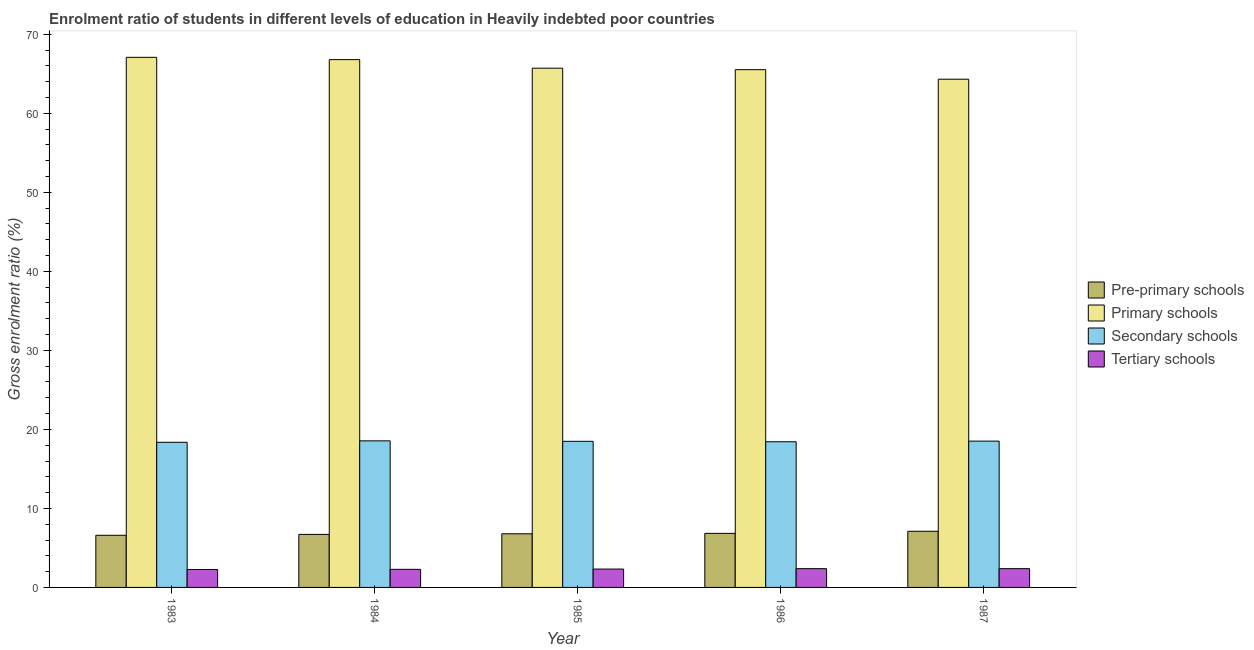How many groups of bars are there?
Your answer should be very brief. 5. Are the number of bars per tick equal to the number of legend labels?
Make the answer very short. Yes. How many bars are there on the 1st tick from the left?
Your response must be concise. 4. In how many cases, is the number of bars for a given year not equal to the number of legend labels?
Offer a terse response. 0. What is the gross enrolment ratio in pre-primary schools in 1984?
Give a very brief answer. 6.71. Across all years, what is the maximum gross enrolment ratio in pre-primary schools?
Your answer should be very brief. 7.11. Across all years, what is the minimum gross enrolment ratio in secondary schools?
Provide a succinct answer. 18.37. What is the total gross enrolment ratio in pre-primary schools in the graph?
Keep it short and to the point. 34.05. What is the difference between the gross enrolment ratio in secondary schools in 1983 and that in 1986?
Your response must be concise. -0.07. What is the difference between the gross enrolment ratio in primary schools in 1985 and the gross enrolment ratio in tertiary schools in 1984?
Your response must be concise. -1.08. What is the average gross enrolment ratio in primary schools per year?
Your response must be concise. 65.89. In the year 1983, what is the difference between the gross enrolment ratio in tertiary schools and gross enrolment ratio in primary schools?
Offer a terse response. 0. In how many years, is the gross enrolment ratio in pre-primary schools greater than 18 %?
Keep it short and to the point. 0. What is the ratio of the gross enrolment ratio in primary schools in 1983 to that in 1984?
Give a very brief answer. 1. Is the gross enrolment ratio in primary schools in 1984 less than that in 1986?
Make the answer very short. No. What is the difference between the highest and the second highest gross enrolment ratio in primary schools?
Keep it short and to the point. 0.29. What is the difference between the highest and the lowest gross enrolment ratio in pre-primary schools?
Keep it short and to the point. 0.51. Is the sum of the gross enrolment ratio in tertiary schools in 1985 and 1987 greater than the maximum gross enrolment ratio in primary schools across all years?
Your answer should be very brief. Yes. Is it the case that in every year, the sum of the gross enrolment ratio in tertiary schools and gross enrolment ratio in secondary schools is greater than the sum of gross enrolment ratio in primary schools and gross enrolment ratio in pre-primary schools?
Ensure brevity in your answer.  No. What does the 3rd bar from the left in 1984 represents?
Make the answer very short. Secondary schools. What does the 2nd bar from the right in 1987 represents?
Provide a short and direct response. Secondary schools. Is it the case that in every year, the sum of the gross enrolment ratio in pre-primary schools and gross enrolment ratio in primary schools is greater than the gross enrolment ratio in secondary schools?
Offer a very short reply. Yes. Are all the bars in the graph horizontal?
Offer a terse response. No. What is the difference between two consecutive major ticks on the Y-axis?
Make the answer very short. 10. Are the values on the major ticks of Y-axis written in scientific E-notation?
Your answer should be very brief. No. Does the graph contain any zero values?
Your answer should be compact. No. Where does the legend appear in the graph?
Your response must be concise. Center right. How many legend labels are there?
Ensure brevity in your answer.  4. How are the legend labels stacked?
Give a very brief answer. Vertical. What is the title of the graph?
Make the answer very short. Enrolment ratio of students in different levels of education in Heavily indebted poor countries. What is the label or title of the Y-axis?
Your response must be concise. Gross enrolment ratio (%). What is the Gross enrolment ratio (%) of Pre-primary schools in 1983?
Provide a short and direct response. 6.6. What is the Gross enrolment ratio (%) of Primary schools in 1983?
Offer a terse response. 67.09. What is the Gross enrolment ratio (%) of Secondary schools in 1983?
Provide a succinct answer. 18.37. What is the Gross enrolment ratio (%) in Tertiary schools in 1983?
Your response must be concise. 2.27. What is the Gross enrolment ratio (%) in Pre-primary schools in 1984?
Provide a short and direct response. 6.71. What is the Gross enrolment ratio (%) in Primary schools in 1984?
Offer a very short reply. 66.8. What is the Gross enrolment ratio (%) in Secondary schools in 1984?
Your response must be concise. 18.55. What is the Gross enrolment ratio (%) of Tertiary schools in 1984?
Your answer should be compact. 2.29. What is the Gross enrolment ratio (%) in Pre-primary schools in 1985?
Offer a very short reply. 6.79. What is the Gross enrolment ratio (%) of Primary schools in 1985?
Ensure brevity in your answer.  65.72. What is the Gross enrolment ratio (%) in Secondary schools in 1985?
Offer a very short reply. 18.49. What is the Gross enrolment ratio (%) of Tertiary schools in 1985?
Give a very brief answer. 2.33. What is the Gross enrolment ratio (%) of Pre-primary schools in 1986?
Keep it short and to the point. 6.84. What is the Gross enrolment ratio (%) in Primary schools in 1986?
Give a very brief answer. 65.53. What is the Gross enrolment ratio (%) of Secondary schools in 1986?
Ensure brevity in your answer.  18.44. What is the Gross enrolment ratio (%) in Tertiary schools in 1986?
Give a very brief answer. 2.38. What is the Gross enrolment ratio (%) in Pre-primary schools in 1987?
Offer a terse response. 7.11. What is the Gross enrolment ratio (%) of Primary schools in 1987?
Your answer should be compact. 64.32. What is the Gross enrolment ratio (%) of Secondary schools in 1987?
Make the answer very short. 18.52. What is the Gross enrolment ratio (%) in Tertiary schools in 1987?
Make the answer very short. 2.38. Across all years, what is the maximum Gross enrolment ratio (%) in Pre-primary schools?
Give a very brief answer. 7.11. Across all years, what is the maximum Gross enrolment ratio (%) in Primary schools?
Make the answer very short. 67.09. Across all years, what is the maximum Gross enrolment ratio (%) in Secondary schools?
Give a very brief answer. 18.55. Across all years, what is the maximum Gross enrolment ratio (%) in Tertiary schools?
Keep it short and to the point. 2.38. Across all years, what is the minimum Gross enrolment ratio (%) of Pre-primary schools?
Give a very brief answer. 6.6. Across all years, what is the minimum Gross enrolment ratio (%) in Primary schools?
Provide a succinct answer. 64.32. Across all years, what is the minimum Gross enrolment ratio (%) of Secondary schools?
Your answer should be very brief. 18.37. Across all years, what is the minimum Gross enrolment ratio (%) in Tertiary schools?
Provide a succinct answer. 2.27. What is the total Gross enrolment ratio (%) in Pre-primary schools in the graph?
Your answer should be compact. 34.05. What is the total Gross enrolment ratio (%) of Primary schools in the graph?
Your answer should be compact. 329.47. What is the total Gross enrolment ratio (%) in Secondary schools in the graph?
Ensure brevity in your answer.  92.37. What is the total Gross enrolment ratio (%) of Tertiary schools in the graph?
Make the answer very short. 11.64. What is the difference between the Gross enrolment ratio (%) of Pre-primary schools in 1983 and that in 1984?
Provide a short and direct response. -0.11. What is the difference between the Gross enrolment ratio (%) of Primary schools in 1983 and that in 1984?
Keep it short and to the point. 0.29. What is the difference between the Gross enrolment ratio (%) in Secondary schools in 1983 and that in 1984?
Your answer should be very brief. -0.18. What is the difference between the Gross enrolment ratio (%) of Tertiary schools in 1983 and that in 1984?
Provide a succinct answer. -0.02. What is the difference between the Gross enrolment ratio (%) of Pre-primary schools in 1983 and that in 1985?
Offer a very short reply. -0.19. What is the difference between the Gross enrolment ratio (%) in Primary schools in 1983 and that in 1985?
Your answer should be very brief. 1.37. What is the difference between the Gross enrolment ratio (%) of Secondary schools in 1983 and that in 1985?
Ensure brevity in your answer.  -0.12. What is the difference between the Gross enrolment ratio (%) in Tertiary schools in 1983 and that in 1985?
Provide a succinct answer. -0.06. What is the difference between the Gross enrolment ratio (%) in Pre-primary schools in 1983 and that in 1986?
Keep it short and to the point. -0.24. What is the difference between the Gross enrolment ratio (%) of Primary schools in 1983 and that in 1986?
Provide a short and direct response. 1.56. What is the difference between the Gross enrolment ratio (%) of Secondary schools in 1983 and that in 1986?
Offer a terse response. -0.07. What is the difference between the Gross enrolment ratio (%) in Tertiary schools in 1983 and that in 1986?
Keep it short and to the point. -0.11. What is the difference between the Gross enrolment ratio (%) of Pre-primary schools in 1983 and that in 1987?
Provide a succinct answer. -0.51. What is the difference between the Gross enrolment ratio (%) in Primary schools in 1983 and that in 1987?
Offer a terse response. 2.77. What is the difference between the Gross enrolment ratio (%) of Secondary schools in 1983 and that in 1987?
Make the answer very short. -0.15. What is the difference between the Gross enrolment ratio (%) in Tertiary schools in 1983 and that in 1987?
Your answer should be compact. -0.11. What is the difference between the Gross enrolment ratio (%) of Pre-primary schools in 1984 and that in 1985?
Your answer should be very brief. -0.08. What is the difference between the Gross enrolment ratio (%) of Primary schools in 1984 and that in 1985?
Provide a succinct answer. 1.08. What is the difference between the Gross enrolment ratio (%) of Secondary schools in 1984 and that in 1985?
Give a very brief answer. 0.06. What is the difference between the Gross enrolment ratio (%) in Tertiary schools in 1984 and that in 1985?
Your answer should be very brief. -0.04. What is the difference between the Gross enrolment ratio (%) of Pre-primary schools in 1984 and that in 1986?
Provide a succinct answer. -0.13. What is the difference between the Gross enrolment ratio (%) of Primary schools in 1984 and that in 1986?
Ensure brevity in your answer.  1.27. What is the difference between the Gross enrolment ratio (%) in Secondary schools in 1984 and that in 1986?
Ensure brevity in your answer.  0.12. What is the difference between the Gross enrolment ratio (%) of Tertiary schools in 1984 and that in 1986?
Ensure brevity in your answer.  -0.09. What is the difference between the Gross enrolment ratio (%) of Pre-primary schools in 1984 and that in 1987?
Ensure brevity in your answer.  -0.39. What is the difference between the Gross enrolment ratio (%) of Primary schools in 1984 and that in 1987?
Your answer should be very brief. 2.48. What is the difference between the Gross enrolment ratio (%) in Secondary schools in 1984 and that in 1987?
Your answer should be very brief. 0.03. What is the difference between the Gross enrolment ratio (%) in Tertiary schools in 1984 and that in 1987?
Offer a terse response. -0.09. What is the difference between the Gross enrolment ratio (%) in Pre-primary schools in 1985 and that in 1986?
Ensure brevity in your answer.  -0.05. What is the difference between the Gross enrolment ratio (%) of Primary schools in 1985 and that in 1986?
Keep it short and to the point. 0.19. What is the difference between the Gross enrolment ratio (%) of Secondary schools in 1985 and that in 1986?
Ensure brevity in your answer.  0.06. What is the difference between the Gross enrolment ratio (%) of Tertiary schools in 1985 and that in 1986?
Your answer should be very brief. -0.05. What is the difference between the Gross enrolment ratio (%) of Pre-primary schools in 1985 and that in 1987?
Offer a very short reply. -0.32. What is the difference between the Gross enrolment ratio (%) of Primary schools in 1985 and that in 1987?
Provide a succinct answer. 1.4. What is the difference between the Gross enrolment ratio (%) in Secondary schools in 1985 and that in 1987?
Keep it short and to the point. -0.02. What is the difference between the Gross enrolment ratio (%) of Tertiary schools in 1985 and that in 1987?
Make the answer very short. -0.05. What is the difference between the Gross enrolment ratio (%) in Pre-primary schools in 1986 and that in 1987?
Your answer should be very brief. -0.26. What is the difference between the Gross enrolment ratio (%) of Primary schools in 1986 and that in 1987?
Make the answer very short. 1.21. What is the difference between the Gross enrolment ratio (%) in Secondary schools in 1986 and that in 1987?
Your answer should be very brief. -0.08. What is the difference between the Gross enrolment ratio (%) in Tertiary schools in 1986 and that in 1987?
Your answer should be compact. -0. What is the difference between the Gross enrolment ratio (%) of Pre-primary schools in 1983 and the Gross enrolment ratio (%) of Primary schools in 1984?
Offer a very short reply. -60.2. What is the difference between the Gross enrolment ratio (%) of Pre-primary schools in 1983 and the Gross enrolment ratio (%) of Secondary schools in 1984?
Your response must be concise. -11.95. What is the difference between the Gross enrolment ratio (%) in Pre-primary schools in 1983 and the Gross enrolment ratio (%) in Tertiary schools in 1984?
Provide a succinct answer. 4.31. What is the difference between the Gross enrolment ratio (%) of Primary schools in 1983 and the Gross enrolment ratio (%) of Secondary schools in 1984?
Your response must be concise. 48.54. What is the difference between the Gross enrolment ratio (%) in Primary schools in 1983 and the Gross enrolment ratio (%) in Tertiary schools in 1984?
Offer a terse response. 64.8. What is the difference between the Gross enrolment ratio (%) of Secondary schools in 1983 and the Gross enrolment ratio (%) of Tertiary schools in 1984?
Provide a succinct answer. 16.08. What is the difference between the Gross enrolment ratio (%) of Pre-primary schools in 1983 and the Gross enrolment ratio (%) of Primary schools in 1985?
Make the answer very short. -59.12. What is the difference between the Gross enrolment ratio (%) of Pre-primary schools in 1983 and the Gross enrolment ratio (%) of Secondary schools in 1985?
Provide a short and direct response. -11.89. What is the difference between the Gross enrolment ratio (%) of Pre-primary schools in 1983 and the Gross enrolment ratio (%) of Tertiary schools in 1985?
Provide a short and direct response. 4.27. What is the difference between the Gross enrolment ratio (%) in Primary schools in 1983 and the Gross enrolment ratio (%) in Secondary schools in 1985?
Offer a very short reply. 48.6. What is the difference between the Gross enrolment ratio (%) in Primary schools in 1983 and the Gross enrolment ratio (%) in Tertiary schools in 1985?
Provide a short and direct response. 64.77. What is the difference between the Gross enrolment ratio (%) in Secondary schools in 1983 and the Gross enrolment ratio (%) in Tertiary schools in 1985?
Make the answer very short. 16.04. What is the difference between the Gross enrolment ratio (%) of Pre-primary schools in 1983 and the Gross enrolment ratio (%) of Primary schools in 1986?
Give a very brief answer. -58.93. What is the difference between the Gross enrolment ratio (%) of Pre-primary schools in 1983 and the Gross enrolment ratio (%) of Secondary schools in 1986?
Keep it short and to the point. -11.84. What is the difference between the Gross enrolment ratio (%) in Pre-primary schools in 1983 and the Gross enrolment ratio (%) in Tertiary schools in 1986?
Ensure brevity in your answer.  4.22. What is the difference between the Gross enrolment ratio (%) of Primary schools in 1983 and the Gross enrolment ratio (%) of Secondary schools in 1986?
Make the answer very short. 48.66. What is the difference between the Gross enrolment ratio (%) of Primary schools in 1983 and the Gross enrolment ratio (%) of Tertiary schools in 1986?
Offer a very short reply. 64.72. What is the difference between the Gross enrolment ratio (%) in Secondary schools in 1983 and the Gross enrolment ratio (%) in Tertiary schools in 1986?
Your response must be concise. 15.99. What is the difference between the Gross enrolment ratio (%) in Pre-primary schools in 1983 and the Gross enrolment ratio (%) in Primary schools in 1987?
Your answer should be compact. -57.72. What is the difference between the Gross enrolment ratio (%) in Pre-primary schools in 1983 and the Gross enrolment ratio (%) in Secondary schools in 1987?
Ensure brevity in your answer.  -11.92. What is the difference between the Gross enrolment ratio (%) of Pre-primary schools in 1983 and the Gross enrolment ratio (%) of Tertiary schools in 1987?
Give a very brief answer. 4.22. What is the difference between the Gross enrolment ratio (%) of Primary schools in 1983 and the Gross enrolment ratio (%) of Secondary schools in 1987?
Keep it short and to the point. 48.58. What is the difference between the Gross enrolment ratio (%) in Primary schools in 1983 and the Gross enrolment ratio (%) in Tertiary schools in 1987?
Your answer should be compact. 64.72. What is the difference between the Gross enrolment ratio (%) in Secondary schools in 1983 and the Gross enrolment ratio (%) in Tertiary schools in 1987?
Offer a terse response. 15.99. What is the difference between the Gross enrolment ratio (%) of Pre-primary schools in 1984 and the Gross enrolment ratio (%) of Primary schools in 1985?
Give a very brief answer. -59.01. What is the difference between the Gross enrolment ratio (%) of Pre-primary schools in 1984 and the Gross enrolment ratio (%) of Secondary schools in 1985?
Your answer should be compact. -11.78. What is the difference between the Gross enrolment ratio (%) in Pre-primary schools in 1984 and the Gross enrolment ratio (%) in Tertiary schools in 1985?
Provide a short and direct response. 4.39. What is the difference between the Gross enrolment ratio (%) in Primary schools in 1984 and the Gross enrolment ratio (%) in Secondary schools in 1985?
Offer a very short reply. 48.31. What is the difference between the Gross enrolment ratio (%) of Primary schools in 1984 and the Gross enrolment ratio (%) of Tertiary schools in 1985?
Give a very brief answer. 64.48. What is the difference between the Gross enrolment ratio (%) in Secondary schools in 1984 and the Gross enrolment ratio (%) in Tertiary schools in 1985?
Offer a terse response. 16.22. What is the difference between the Gross enrolment ratio (%) in Pre-primary schools in 1984 and the Gross enrolment ratio (%) in Primary schools in 1986?
Your answer should be very brief. -58.82. What is the difference between the Gross enrolment ratio (%) of Pre-primary schools in 1984 and the Gross enrolment ratio (%) of Secondary schools in 1986?
Give a very brief answer. -11.72. What is the difference between the Gross enrolment ratio (%) in Pre-primary schools in 1984 and the Gross enrolment ratio (%) in Tertiary schools in 1986?
Keep it short and to the point. 4.34. What is the difference between the Gross enrolment ratio (%) of Primary schools in 1984 and the Gross enrolment ratio (%) of Secondary schools in 1986?
Your answer should be compact. 48.37. What is the difference between the Gross enrolment ratio (%) of Primary schools in 1984 and the Gross enrolment ratio (%) of Tertiary schools in 1986?
Offer a terse response. 64.43. What is the difference between the Gross enrolment ratio (%) of Secondary schools in 1984 and the Gross enrolment ratio (%) of Tertiary schools in 1986?
Keep it short and to the point. 16.17. What is the difference between the Gross enrolment ratio (%) in Pre-primary schools in 1984 and the Gross enrolment ratio (%) in Primary schools in 1987?
Your response must be concise. -57.61. What is the difference between the Gross enrolment ratio (%) in Pre-primary schools in 1984 and the Gross enrolment ratio (%) in Secondary schools in 1987?
Make the answer very short. -11.8. What is the difference between the Gross enrolment ratio (%) in Pre-primary schools in 1984 and the Gross enrolment ratio (%) in Tertiary schools in 1987?
Give a very brief answer. 4.34. What is the difference between the Gross enrolment ratio (%) in Primary schools in 1984 and the Gross enrolment ratio (%) in Secondary schools in 1987?
Offer a terse response. 48.29. What is the difference between the Gross enrolment ratio (%) of Primary schools in 1984 and the Gross enrolment ratio (%) of Tertiary schools in 1987?
Give a very brief answer. 64.43. What is the difference between the Gross enrolment ratio (%) of Secondary schools in 1984 and the Gross enrolment ratio (%) of Tertiary schools in 1987?
Ensure brevity in your answer.  16.17. What is the difference between the Gross enrolment ratio (%) in Pre-primary schools in 1985 and the Gross enrolment ratio (%) in Primary schools in 1986?
Your answer should be very brief. -58.74. What is the difference between the Gross enrolment ratio (%) in Pre-primary schools in 1985 and the Gross enrolment ratio (%) in Secondary schools in 1986?
Provide a short and direct response. -11.65. What is the difference between the Gross enrolment ratio (%) of Pre-primary schools in 1985 and the Gross enrolment ratio (%) of Tertiary schools in 1986?
Ensure brevity in your answer.  4.41. What is the difference between the Gross enrolment ratio (%) in Primary schools in 1985 and the Gross enrolment ratio (%) in Secondary schools in 1986?
Your response must be concise. 47.28. What is the difference between the Gross enrolment ratio (%) in Primary schools in 1985 and the Gross enrolment ratio (%) in Tertiary schools in 1986?
Give a very brief answer. 63.34. What is the difference between the Gross enrolment ratio (%) of Secondary schools in 1985 and the Gross enrolment ratio (%) of Tertiary schools in 1986?
Give a very brief answer. 16.12. What is the difference between the Gross enrolment ratio (%) of Pre-primary schools in 1985 and the Gross enrolment ratio (%) of Primary schools in 1987?
Offer a very short reply. -57.53. What is the difference between the Gross enrolment ratio (%) in Pre-primary schools in 1985 and the Gross enrolment ratio (%) in Secondary schools in 1987?
Your response must be concise. -11.73. What is the difference between the Gross enrolment ratio (%) of Pre-primary schools in 1985 and the Gross enrolment ratio (%) of Tertiary schools in 1987?
Offer a very short reply. 4.41. What is the difference between the Gross enrolment ratio (%) in Primary schools in 1985 and the Gross enrolment ratio (%) in Secondary schools in 1987?
Your answer should be compact. 47.2. What is the difference between the Gross enrolment ratio (%) of Primary schools in 1985 and the Gross enrolment ratio (%) of Tertiary schools in 1987?
Provide a succinct answer. 63.34. What is the difference between the Gross enrolment ratio (%) in Secondary schools in 1985 and the Gross enrolment ratio (%) in Tertiary schools in 1987?
Keep it short and to the point. 16.12. What is the difference between the Gross enrolment ratio (%) of Pre-primary schools in 1986 and the Gross enrolment ratio (%) of Primary schools in 1987?
Keep it short and to the point. -57.48. What is the difference between the Gross enrolment ratio (%) in Pre-primary schools in 1986 and the Gross enrolment ratio (%) in Secondary schools in 1987?
Offer a very short reply. -11.67. What is the difference between the Gross enrolment ratio (%) of Pre-primary schools in 1986 and the Gross enrolment ratio (%) of Tertiary schools in 1987?
Offer a very short reply. 4.47. What is the difference between the Gross enrolment ratio (%) in Primary schools in 1986 and the Gross enrolment ratio (%) in Secondary schools in 1987?
Give a very brief answer. 47.01. What is the difference between the Gross enrolment ratio (%) of Primary schools in 1986 and the Gross enrolment ratio (%) of Tertiary schools in 1987?
Offer a very short reply. 63.15. What is the difference between the Gross enrolment ratio (%) in Secondary schools in 1986 and the Gross enrolment ratio (%) in Tertiary schools in 1987?
Your response must be concise. 16.06. What is the average Gross enrolment ratio (%) in Pre-primary schools per year?
Your response must be concise. 6.81. What is the average Gross enrolment ratio (%) in Primary schools per year?
Provide a short and direct response. 65.89. What is the average Gross enrolment ratio (%) of Secondary schools per year?
Your answer should be compact. 18.47. What is the average Gross enrolment ratio (%) of Tertiary schools per year?
Your response must be concise. 2.33. In the year 1983, what is the difference between the Gross enrolment ratio (%) of Pre-primary schools and Gross enrolment ratio (%) of Primary schools?
Offer a terse response. -60.49. In the year 1983, what is the difference between the Gross enrolment ratio (%) of Pre-primary schools and Gross enrolment ratio (%) of Secondary schools?
Ensure brevity in your answer.  -11.77. In the year 1983, what is the difference between the Gross enrolment ratio (%) of Pre-primary schools and Gross enrolment ratio (%) of Tertiary schools?
Make the answer very short. 4.33. In the year 1983, what is the difference between the Gross enrolment ratio (%) of Primary schools and Gross enrolment ratio (%) of Secondary schools?
Offer a very short reply. 48.72. In the year 1983, what is the difference between the Gross enrolment ratio (%) of Primary schools and Gross enrolment ratio (%) of Tertiary schools?
Provide a succinct answer. 64.82. In the year 1983, what is the difference between the Gross enrolment ratio (%) of Secondary schools and Gross enrolment ratio (%) of Tertiary schools?
Keep it short and to the point. 16.1. In the year 1984, what is the difference between the Gross enrolment ratio (%) of Pre-primary schools and Gross enrolment ratio (%) of Primary schools?
Provide a succinct answer. -60.09. In the year 1984, what is the difference between the Gross enrolment ratio (%) in Pre-primary schools and Gross enrolment ratio (%) in Secondary schools?
Your answer should be very brief. -11.84. In the year 1984, what is the difference between the Gross enrolment ratio (%) in Pre-primary schools and Gross enrolment ratio (%) in Tertiary schools?
Ensure brevity in your answer.  4.42. In the year 1984, what is the difference between the Gross enrolment ratio (%) in Primary schools and Gross enrolment ratio (%) in Secondary schools?
Give a very brief answer. 48.25. In the year 1984, what is the difference between the Gross enrolment ratio (%) in Primary schools and Gross enrolment ratio (%) in Tertiary schools?
Your answer should be compact. 64.51. In the year 1984, what is the difference between the Gross enrolment ratio (%) of Secondary schools and Gross enrolment ratio (%) of Tertiary schools?
Offer a very short reply. 16.26. In the year 1985, what is the difference between the Gross enrolment ratio (%) in Pre-primary schools and Gross enrolment ratio (%) in Primary schools?
Ensure brevity in your answer.  -58.93. In the year 1985, what is the difference between the Gross enrolment ratio (%) of Pre-primary schools and Gross enrolment ratio (%) of Secondary schools?
Offer a very short reply. -11.7. In the year 1985, what is the difference between the Gross enrolment ratio (%) of Pre-primary schools and Gross enrolment ratio (%) of Tertiary schools?
Keep it short and to the point. 4.46. In the year 1985, what is the difference between the Gross enrolment ratio (%) of Primary schools and Gross enrolment ratio (%) of Secondary schools?
Your answer should be very brief. 47.23. In the year 1985, what is the difference between the Gross enrolment ratio (%) of Primary schools and Gross enrolment ratio (%) of Tertiary schools?
Give a very brief answer. 63.39. In the year 1985, what is the difference between the Gross enrolment ratio (%) of Secondary schools and Gross enrolment ratio (%) of Tertiary schools?
Your answer should be compact. 16.17. In the year 1986, what is the difference between the Gross enrolment ratio (%) in Pre-primary schools and Gross enrolment ratio (%) in Primary schools?
Ensure brevity in your answer.  -58.69. In the year 1986, what is the difference between the Gross enrolment ratio (%) in Pre-primary schools and Gross enrolment ratio (%) in Secondary schools?
Provide a short and direct response. -11.59. In the year 1986, what is the difference between the Gross enrolment ratio (%) of Pre-primary schools and Gross enrolment ratio (%) of Tertiary schools?
Offer a terse response. 4.47. In the year 1986, what is the difference between the Gross enrolment ratio (%) in Primary schools and Gross enrolment ratio (%) in Secondary schools?
Ensure brevity in your answer.  47.09. In the year 1986, what is the difference between the Gross enrolment ratio (%) of Primary schools and Gross enrolment ratio (%) of Tertiary schools?
Provide a succinct answer. 63.15. In the year 1986, what is the difference between the Gross enrolment ratio (%) of Secondary schools and Gross enrolment ratio (%) of Tertiary schools?
Provide a short and direct response. 16.06. In the year 1987, what is the difference between the Gross enrolment ratio (%) in Pre-primary schools and Gross enrolment ratio (%) in Primary schools?
Provide a short and direct response. -57.22. In the year 1987, what is the difference between the Gross enrolment ratio (%) in Pre-primary schools and Gross enrolment ratio (%) in Secondary schools?
Ensure brevity in your answer.  -11.41. In the year 1987, what is the difference between the Gross enrolment ratio (%) in Pre-primary schools and Gross enrolment ratio (%) in Tertiary schools?
Provide a succinct answer. 4.73. In the year 1987, what is the difference between the Gross enrolment ratio (%) of Primary schools and Gross enrolment ratio (%) of Secondary schools?
Ensure brevity in your answer.  45.81. In the year 1987, what is the difference between the Gross enrolment ratio (%) in Primary schools and Gross enrolment ratio (%) in Tertiary schools?
Ensure brevity in your answer.  61.95. In the year 1987, what is the difference between the Gross enrolment ratio (%) of Secondary schools and Gross enrolment ratio (%) of Tertiary schools?
Give a very brief answer. 16.14. What is the ratio of the Gross enrolment ratio (%) of Pre-primary schools in 1983 to that in 1984?
Your answer should be very brief. 0.98. What is the ratio of the Gross enrolment ratio (%) in Primary schools in 1983 to that in 1984?
Provide a short and direct response. 1. What is the ratio of the Gross enrolment ratio (%) of Secondary schools in 1983 to that in 1984?
Give a very brief answer. 0.99. What is the ratio of the Gross enrolment ratio (%) in Tertiary schools in 1983 to that in 1984?
Ensure brevity in your answer.  0.99. What is the ratio of the Gross enrolment ratio (%) in Pre-primary schools in 1983 to that in 1985?
Make the answer very short. 0.97. What is the ratio of the Gross enrolment ratio (%) of Primary schools in 1983 to that in 1985?
Keep it short and to the point. 1.02. What is the ratio of the Gross enrolment ratio (%) in Tertiary schools in 1983 to that in 1985?
Keep it short and to the point. 0.97. What is the ratio of the Gross enrolment ratio (%) of Pre-primary schools in 1983 to that in 1986?
Your answer should be very brief. 0.96. What is the ratio of the Gross enrolment ratio (%) of Primary schools in 1983 to that in 1986?
Offer a very short reply. 1.02. What is the ratio of the Gross enrolment ratio (%) in Secondary schools in 1983 to that in 1986?
Offer a terse response. 1. What is the ratio of the Gross enrolment ratio (%) of Tertiary schools in 1983 to that in 1986?
Give a very brief answer. 0.95. What is the ratio of the Gross enrolment ratio (%) in Pre-primary schools in 1983 to that in 1987?
Your answer should be compact. 0.93. What is the ratio of the Gross enrolment ratio (%) of Primary schools in 1983 to that in 1987?
Your response must be concise. 1.04. What is the ratio of the Gross enrolment ratio (%) of Secondary schools in 1983 to that in 1987?
Your answer should be very brief. 0.99. What is the ratio of the Gross enrolment ratio (%) in Tertiary schools in 1983 to that in 1987?
Provide a short and direct response. 0.95. What is the ratio of the Gross enrolment ratio (%) in Pre-primary schools in 1984 to that in 1985?
Provide a succinct answer. 0.99. What is the ratio of the Gross enrolment ratio (%) in Primary schools in 1984 to that in 1985?
Make the answer very short. 1.02. What is the ratio of the Gross enrolment ratio (%) of Tertiary schools in 1984 to that in 1985?
Provide a short and direct response. 0.98. What is the ratio of the Gross enrolment ratio (%) of Primary schools in 1984 to that in 1986?
Ensure brevity in your answer.  1.02. What is the ratio of the Gross enrolment ratio (%) in Tertiary schools in 1984 to that in 1986?
Your response must be concise. 0.96. What is the ratio of the Gross enrolment ratio (%) of Pre-primary schools in 1984 to that in 1987?
Give a very brief answer. 0.94. What is the ratio of the Gross enrolment ratio (%) of Primary schools in 1984 to that in 1987?
Your answer should be compact. 1.04. What is the ratio of the Gross enrolment ratio (%) in Secondary schools in 1984 to that in 1987?
Give a very brief answer. 1. What is the ratio of the Gross enrolment ratio (%) of Tertiary schools in 1984 to that in 1987?
Offer a very short reply. 0.96. What is the ratio of the Gross enrolment ratio (%) in Pre-primary schools in 1985 to that in 1986?
Your answer should be very brief. 0.99. What is the ratio of the Gross enrolment ratio (%) of Primary schools in 1985 to that in 1986?
Ensure brevity in your answer.  1. What is the ratio of the Gross enrolment ratio (%) in Tertiary schools in 1985 to that in 1986?
Provide a succinct answer. 0.98. What is the ratio of the Gross enrolment ratio (%) of Pre-primary schools in 1985 to that in 1987?
Offer a terse response. 0.96. What is the ratio of the Gross enrolment ratio (%) of Primary schools in 1985 to that in 1987?
Offer a terse response. 1.02. What is the ratio of the Gross enrolment ratio (%) in Secondary schools in 1985 to that in 1987?
Keep it short and to the point. 1. What is the ratio of the Gross enrolment ratio (%) of Tertiary schools in 1985 to that in 1987?
Ensure brevity in your answer.  0.98. What is the ratio of the Gross enrolment ratio (%) in Pre-primary schools in 1986 to that in 1987?
Provide a succinct answer. 0.96. What is the ratio of the Gross enrolment ratio (%) in Primary schools in 1986 to that in 1987?
Keep it short and to the point. 1.02. What is the difference between the highest and the second highest Gross enrolment ratio (%) of Pre-primary schools?
Keep it short and to the point. 0.26. What is the difference between the highest and the second highest Gross enrolment ratio (%) of Primary schools?
Offer a very short reply. 0.29. What is the difference between the highest and the second highest Gross enrolment ratio (%) in Secondary schools?
Give a very brief answer. 0.03. What is the difference between the highest and the lowest Gross enrolment ratio (%) in Pre-primary schools?
Provide a short and direct response. 0.51. What is the difference between the highest and the lowest Gross enrolment ratio (%) of Primary schools?
Provide a short and direct response. 2.77. What is the difference between the highest and the lowest Gross enrolment ratio (%) of Secondary schools?
Your response must be concise. 0.18. What is the difference between the highest and the lowest Gross enrolment ratio (%) in Tertiary schools?
Provide a succinct answer. 0.11. 